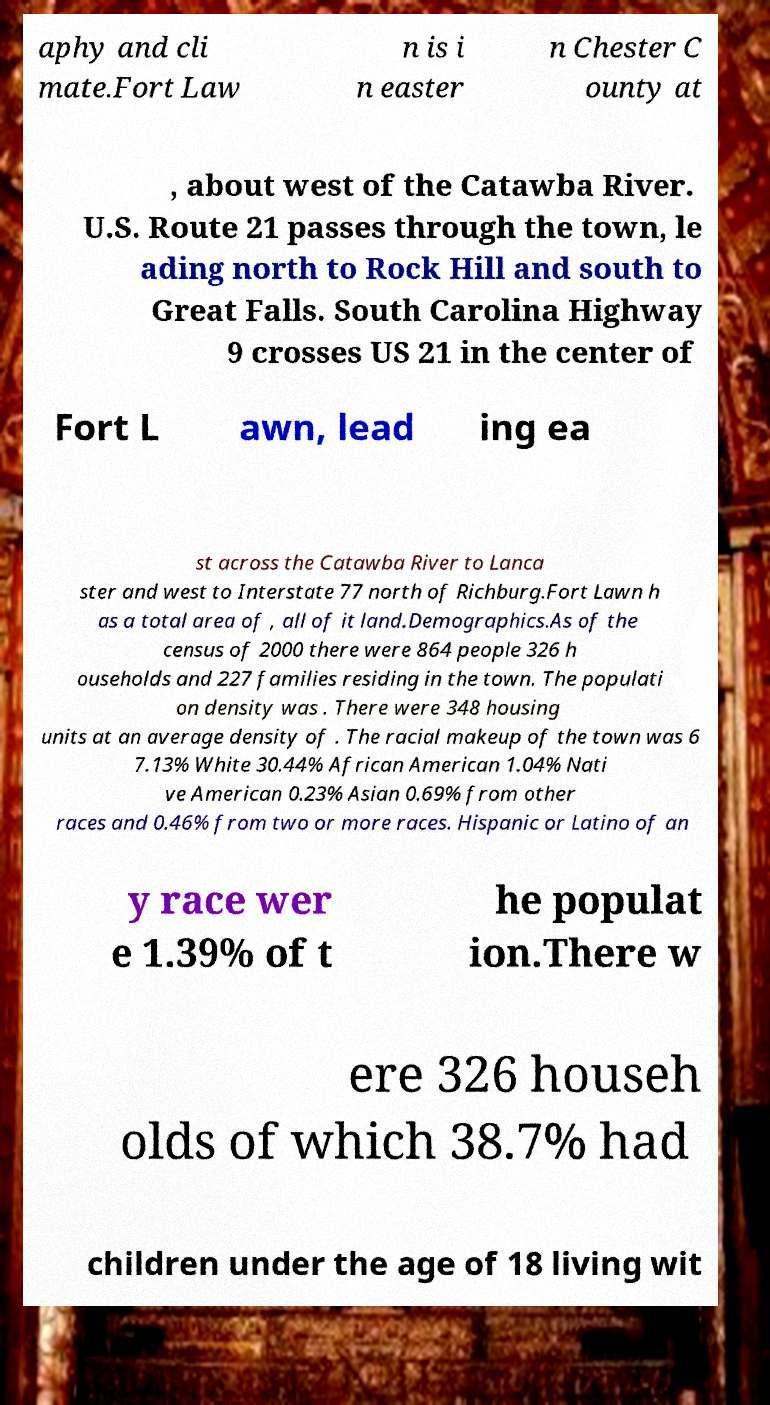Please read and relay the text visible in this image. What does it say? aphy and cli mate.Fort Law n is i n easter n Chester C ounty at , about west of the Catawba River. U.S. Route 21 passes through the town, le ading north to Rock Hill and south to Great Falls. South Carolina Highway 9 crosses US 21 in the center of Fort L awn, lead ing ea st across the Catawba River to Lanca ster and west to Interstate 77 north of Richburg.Fort Lawn h as a total area of , all of it land.Demographics.As of the census of 2000 there were 864 people 326 h ouseholds and 227 families residing in the town. The populati on density was . There were 348 housing units at an average density of . The racial makeup of the town was 6 7.13% White 30.44% African American 1.04% Nati ve American 0.23% Asian 0.69% from other races and 0.46% from two or more races. Hispanic or Latino of an y race wer e 1.39% of t he populat ion.There w ere 326 househ olds of which 38.7% had children under the age of 18 living wit 